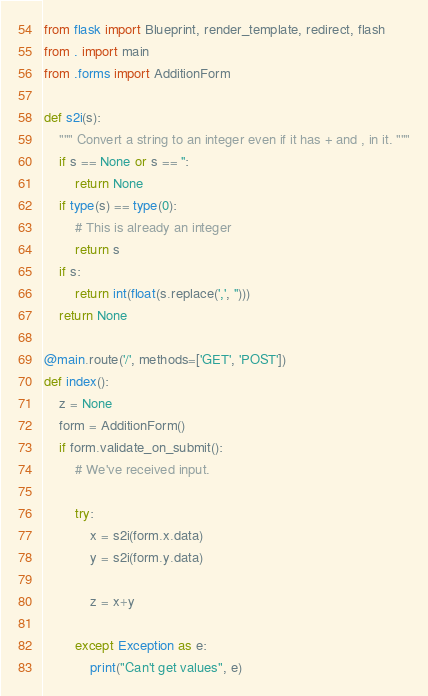Convert code to text. <code><loc_0><loc_0><loc_500><loc_500><_Python_>from flask import Blueprint, render_template, redirect, flash
from . import main
from .forms import AdditionForm

def s2i(s):
    """ Convert a string to an integer even if it has + and , in it. """
    if s == None or s == '':
        return None
    if type(s) == type(0):
        # This is already an integer
        return s
    if s:
        return int(float(s.replace(',', '')))
    return None

@main.route('/', methods=['GET', 'POST'])
def index():
    z = None
    form = AdditionForm()
    if form.validate_on_submit():
        # We've received input.

        try:
            x = s2i(form.x.data)
            y = s2i(form.y.data)

            z = x+y

        except Exception as e:
            print("Can't get values", e)</code> 